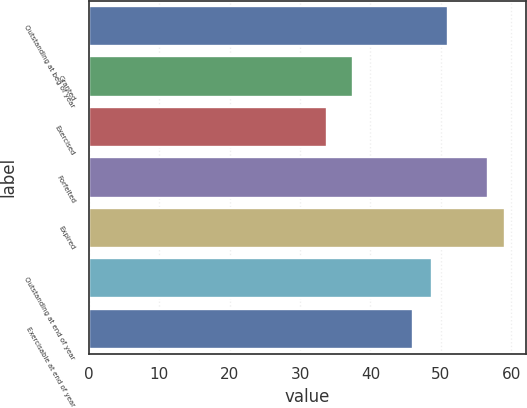Convert chart. <chart><loc_0><loc_0><loc_500><loc_500><bar_chart><fcel>Outstanding at beg of year<fcel>Granted<fcel>Exercised<fcel>Forfeited<fcel>Expired<fcel>Outstanding at end of year<fcel>Exercisable at end of year<nl><fcel>51.02<fcel>37.54<fcel>33.89<fcel>56.76<fcel>59.09<fcel>48.69<fcel>46.02<nl></chart> 